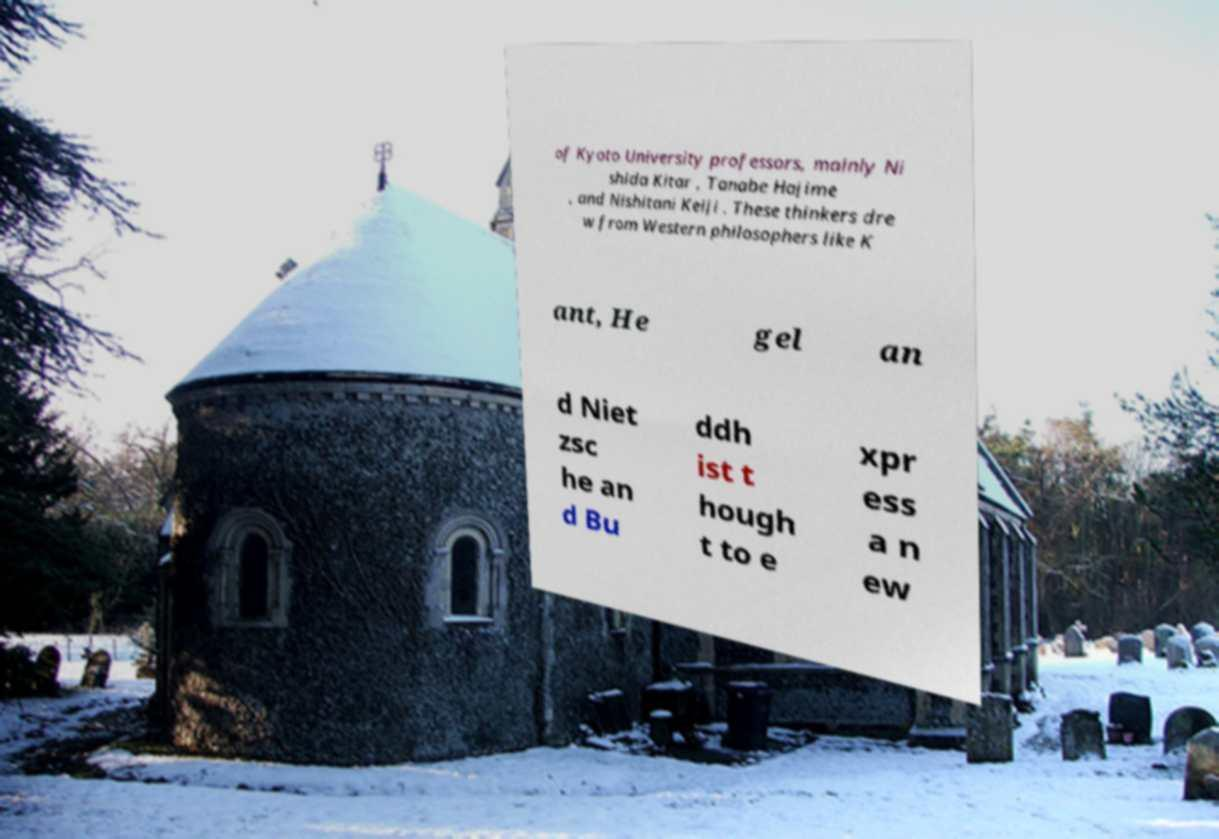There's text embedded in this image that I need extracted. Can you transcribe it verbatim? of Kyoto University professors, mainly Ni shida Kitar , Tanabe Hajime , and Nishitani Keiji . These thinkers dre w from Western philosophers like K ant, He gel an d Niet zsc he an d Bu ddh ist t hough t to e xpr ess a n ew 